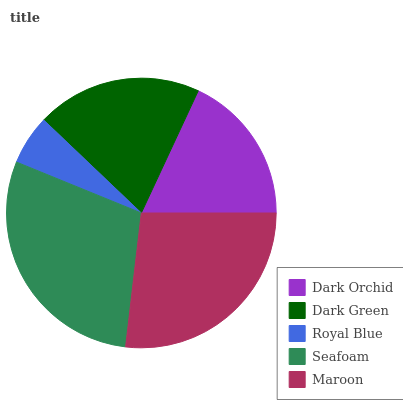Is Royal Blue the minimum?
Answer yes or no. Yes. Is Seafoam the maximum?
Answer yes or no. Yes. Is Dark Green the minimum?
Answer yes or no. No. Is Dark Green the maximum?
Answer yes or no. No. Is Dark Green greater than Dark Orchid?
Answer yes or no. Yes. Is Dark Orchid less than Dark Green?
Answer yes or no. Yes. Is Dark Orchid greater than Dark Green?
Answer yes or no. No. Is Dark Green less than Dark Orchid?
Answer yes or no. No. Is Dark Green the high median?
Answer yes or no. Yes. Is Dark Green the low median?
Answer yes or no. Yes. Is Royal Blue the high median?
Answer yes or no. No. Is Dark Orchid the low median?
Answer yes or no. No. 